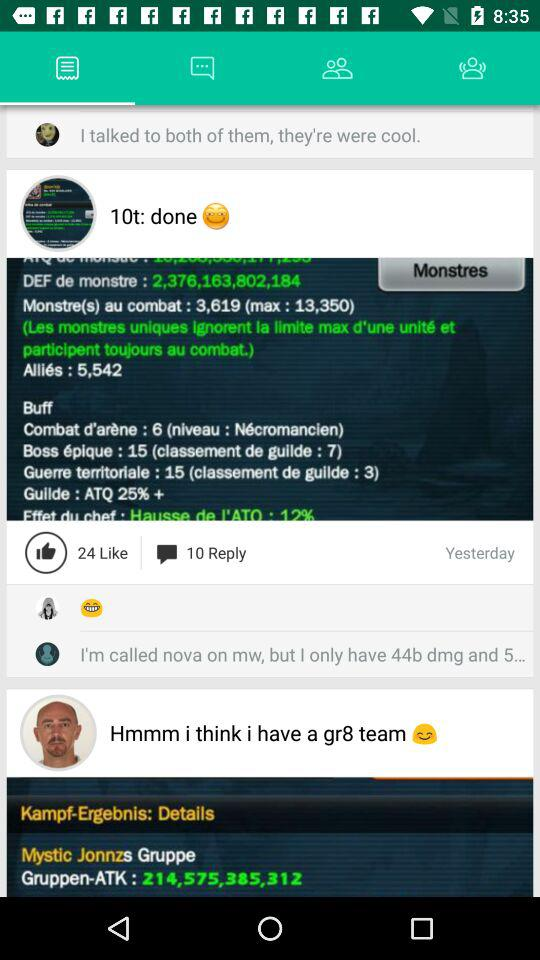How many likes are there on this post?
Answer the question using a single word or phrase. 24 